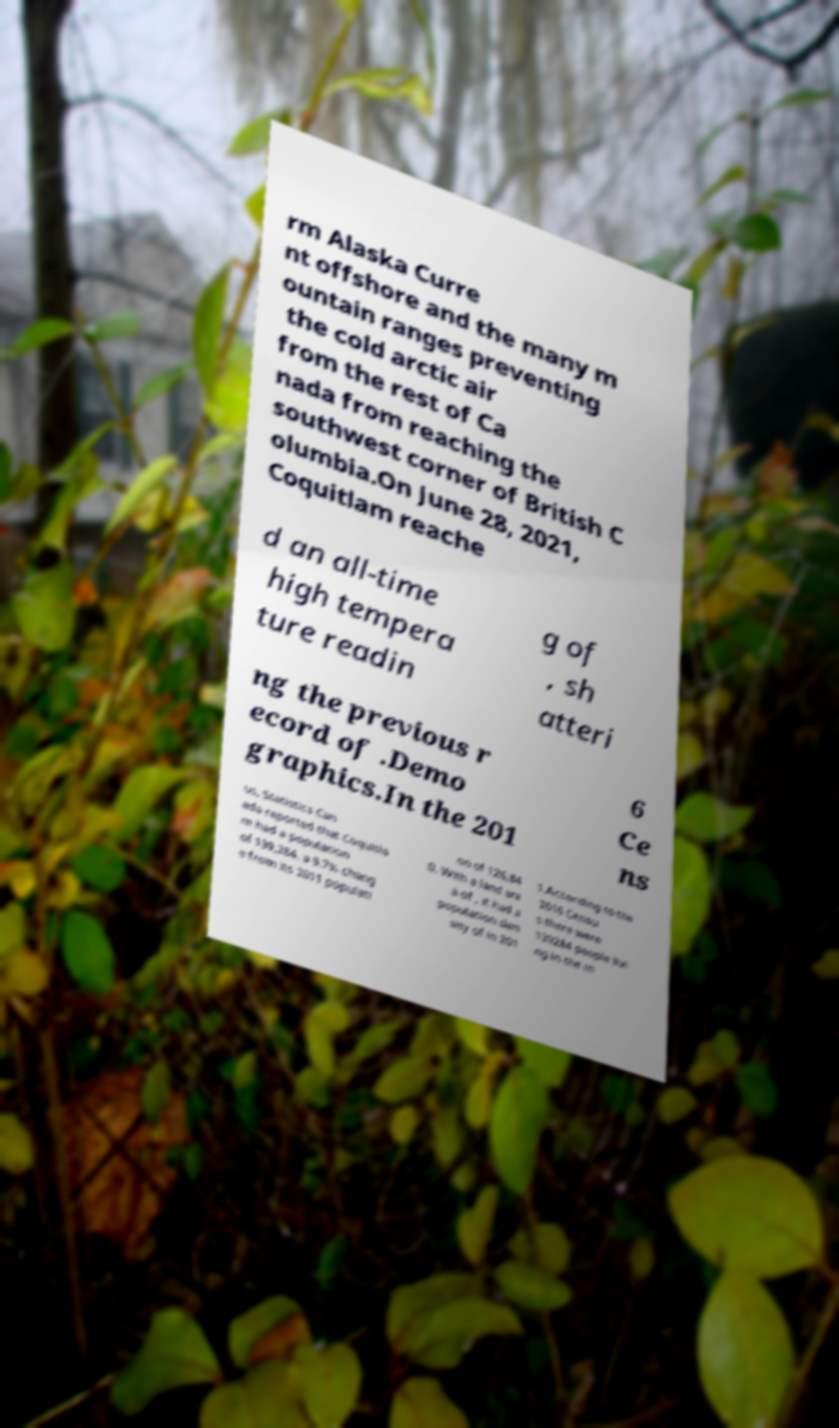Can you accurately transcribe the text from the provided image for me? rm Alaska Curre nt offshore and the many m ountain ranges preventing the cold arctic air from the rest of Ca nada from reaching the southwest corner of British C olumbia.On June 28, 2021, Coquitlam reache d an all-time high tempera ture readin g of , sh atteri ng the previous r ecord of .Demo graphics.In the 201 6 Ce ns us, Statistics Can ada reported that Coquitla m had a population of 139,284, a 9.7% chang e from its 2011 populati on of 126,84 0. With a land are a of , it had a population den sity of in 201 1.According to the 2016 Censu s there were 139284 people livi ng in the m 